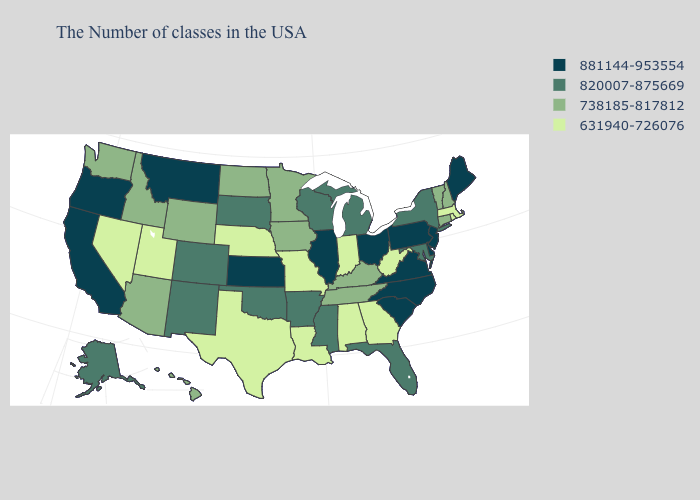What is the highest value in the USA?
Short answer required. 881144-953554. Name the states that have a value in the range 881144-953554?
Be succinct. Maine, New Jersey, Delaware, Pennsylvania, Virginia, North Carolina, South Carolina, Ohio, Illinois, Kansas, Montana, California, Oregon. Name the states that have a value in the range 820007-875669?
Concise answer only. New York, Maryland, Florida, Michigan, Wisconsin, Mississippi, Arkansas, Oklahoma, South Dakota, Colorado, New Mexico, Alaska. Among the states that border Delaware , which have the lowest value?
Give a very brief answer. Maryland. What is the value of Mississippi?
Write a very short answer. 820007-875669. Does Connecticut have the same value as Tennessee?
Quick response, please. Yes. Does Utah have the lowest value in the USA?
Write a very short answer. Yes. Name the states that have a value in the range 738185-817812?
Quick response, please. New Hampshire, Vermont, Connecticut, Kentucky, Tennessee, Minnesota, Iowa, North Dakota, Wyoming, Arizona, Idaho, Washington, Hawaii. What is the value of Ohio?
Write a very short answer. 881144-953554. What is the value of Ohio?
Quick response, please. 881144-953554. Name the states that have a value in the range 631940-726076?
Quick response, please. Massachusetts, Rhode Island, West Virginia, Georgia, Indiana, Alabama, Louisiana, Missouri, Nebraska, Texas, Utah, Nevada. Which states have the lowest value in the Northeast?
Short answer required. Massachusetts, Rhode Island. Among the states that border Arkansas , does Texas have the lowest value?
Give a very brief answer. Yes. Among the states that border Pennsylvania , which have the lowest value?
Answer briefly. West Virginia. Among the states that border Indiana , does Kentucky have the highest value?
Concise answer only. No. 